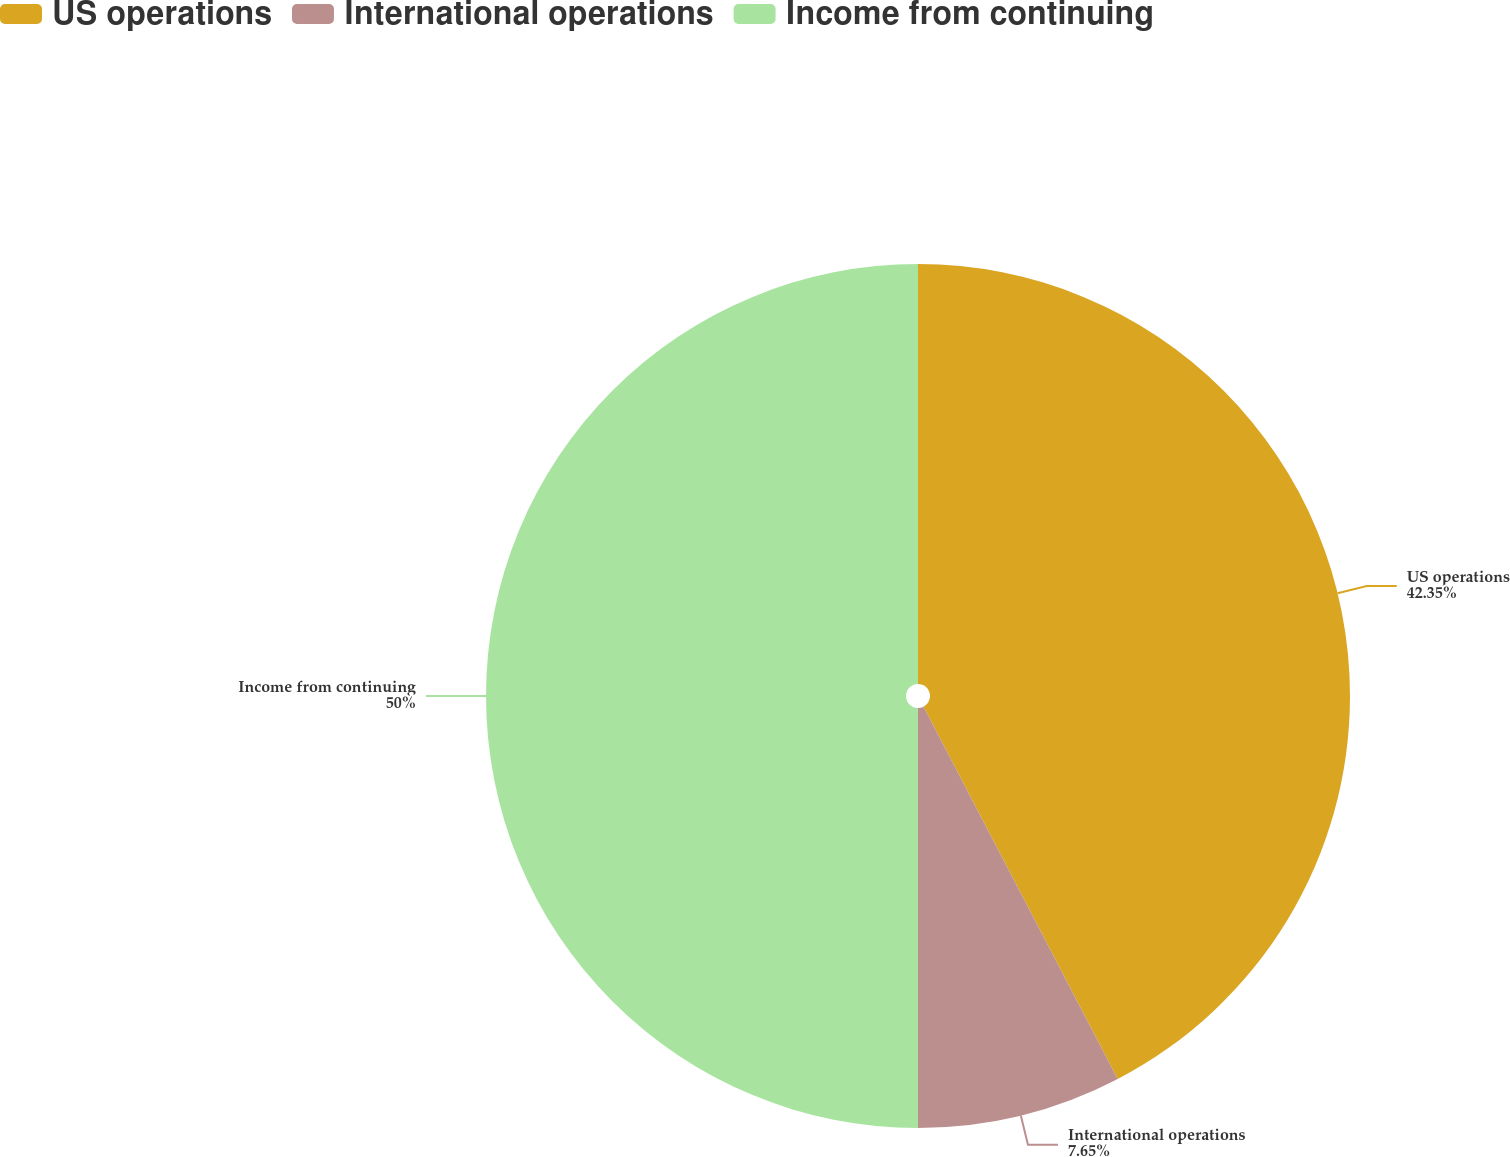Convert chart. <chart><loc_0><loc_0><loc_500><loc_500><pie_chart><fcel>US operations<fcel>International operations<fcel>Income from continuing<nl><fcel>42.35%<fcel>7.65%<fcel>50.0%<nl></chart> 